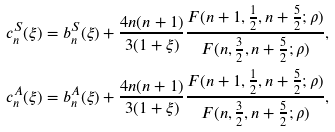<formula> <loc_0><loc_0><loc_500><loc_500>c _ { n } ^ { S } ( \xi ) & = b _ { n } ^ { S } ( \xi ) + \frac { 4 n ( n + 1 ) } { 3 ( 1 + \xi ) } \frac { F ( n + 1 , \frac { 1 } { 2 } , n + \frac { 5 } { 2 } ; \rho ) } { F ( n , \frac { 3 } { 2 } , n + \frac { 5 } { 2 } ; \rho ) } , \\ c _ { n } ^ { A } ( \xi ) & = b _ { n } ^ { A } ( \xi ) + \frac { 4 n ( n + 1 ) } { 3 ( 1 + \xi ) } \frac { F ( n + 1 , \frac { 1 } { 2 } , n + \frac { 5 } { 2 } ; \rho ) } { F ( n , \frac { 3 } { 2 } , n + \frac { 5 } { 2 } ; \rho ) } ,</formula> 